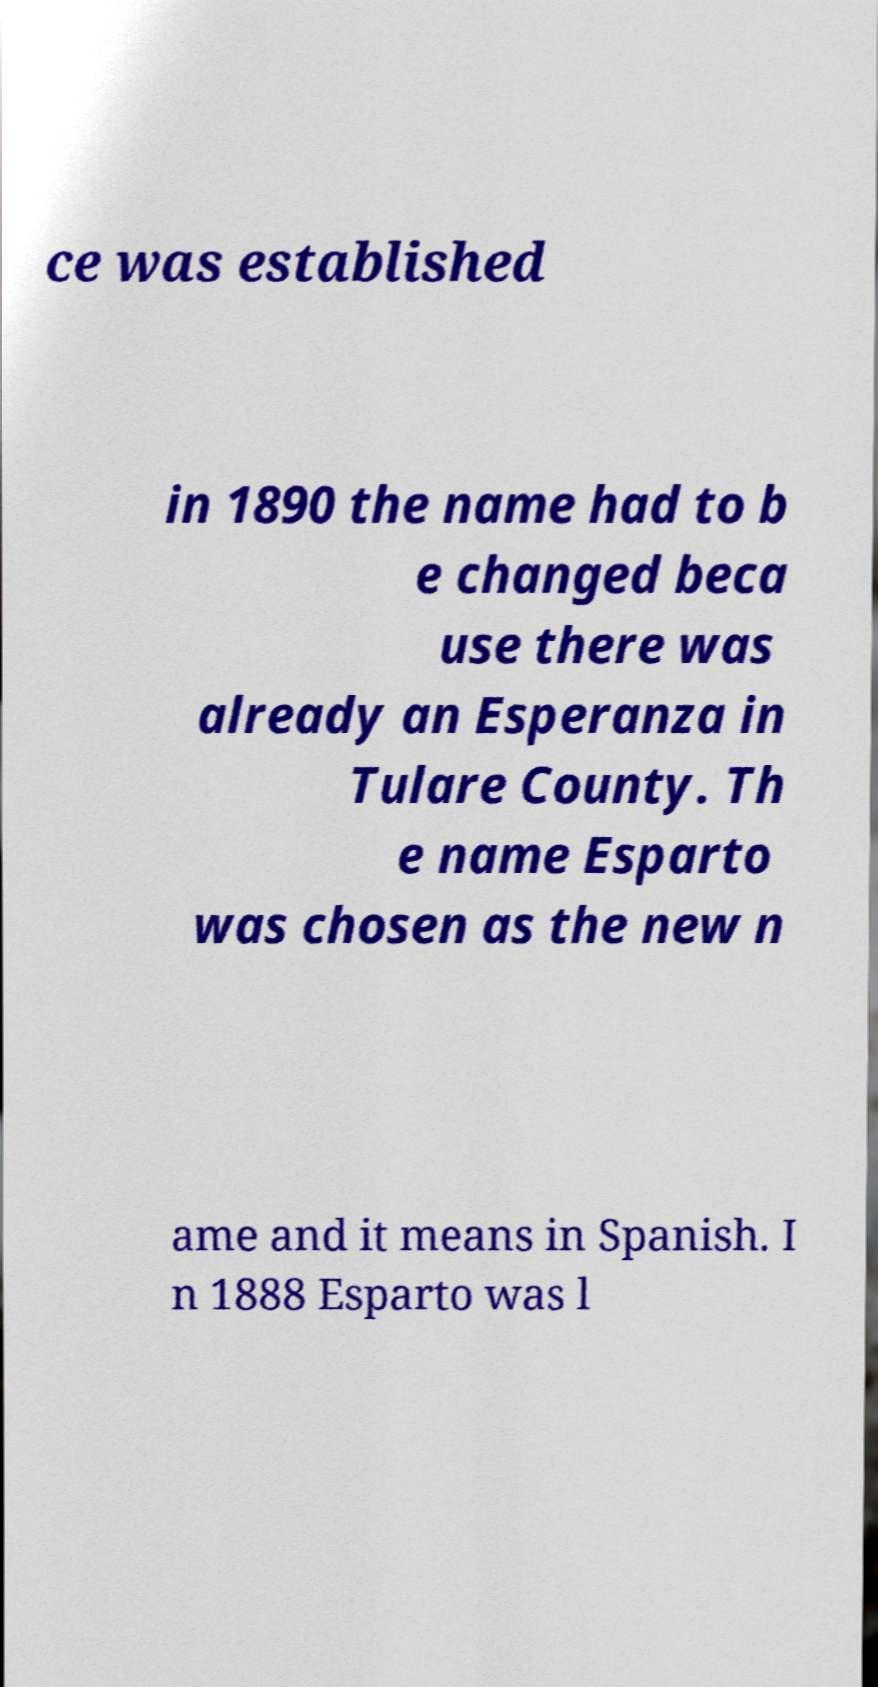What messages or text are displayed in this image? I need them in a readable, typed format. ce was established in 1890 the name had to b e changed beca use there was already an Esperanza in Tulare County. Th e name Esparto was chosen as the new n ame and it means in Spanish. I n 1888 Esparto was l 